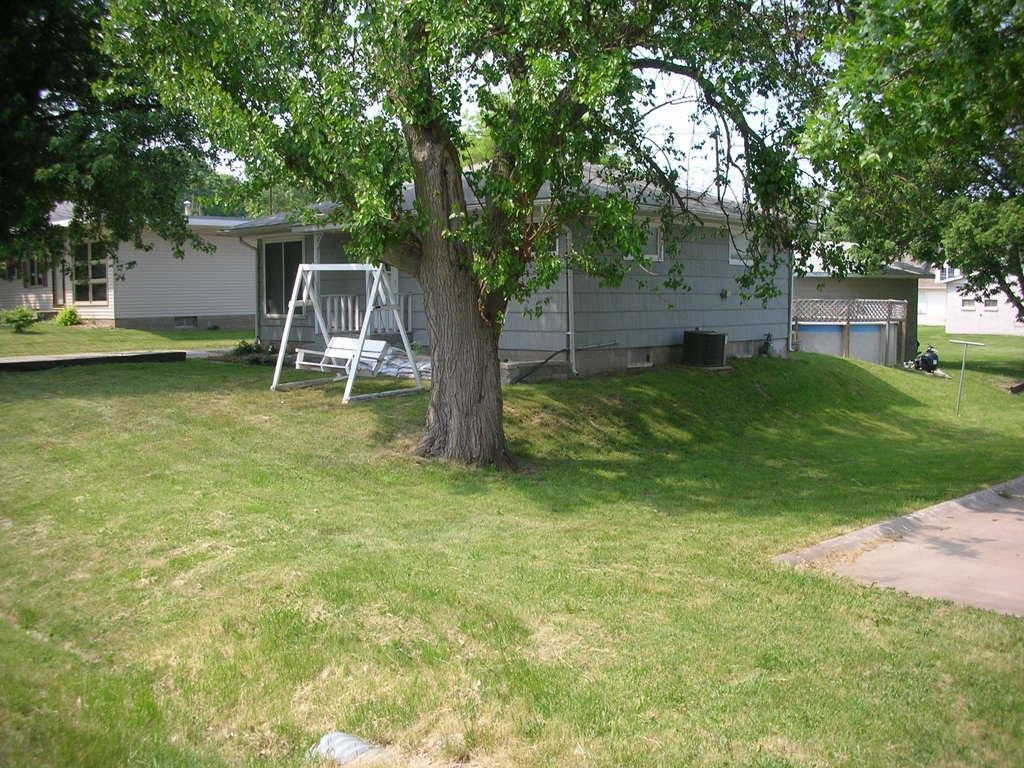Could you give a brief overview of what you see in this image? In the center of the image we can see trees, houses, swinging bench are there. At the bottom of the image ground is there. On the left side of the image some plants are there. At the top of the image sky is there. 